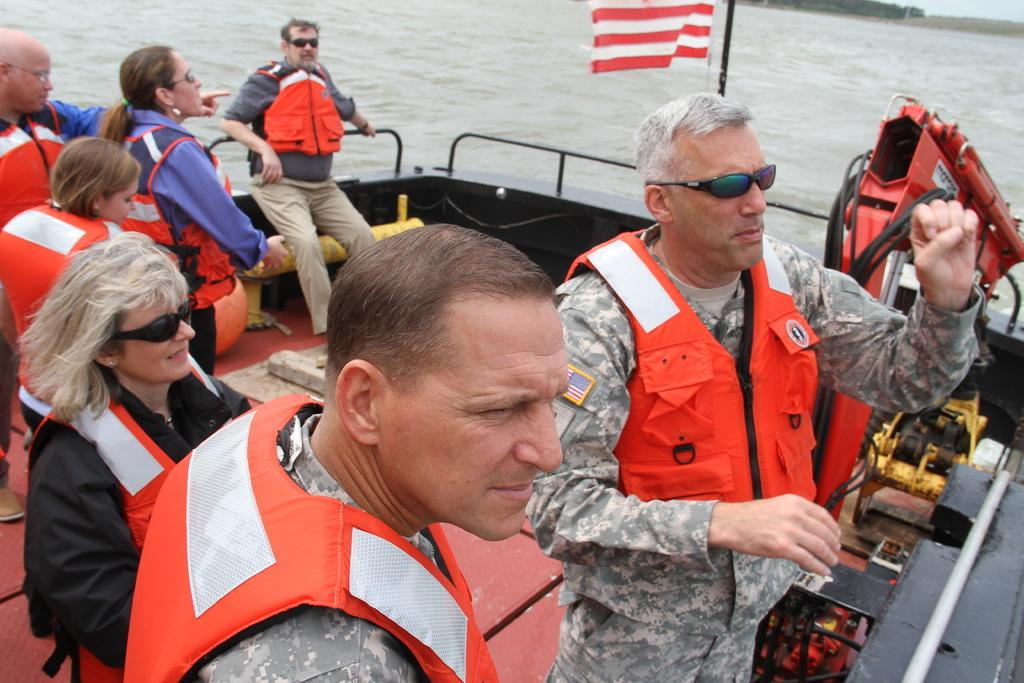How many people are in the image? There is a group of persons in the image. What are the persons doing in the image? The persons are standing in a boat. What are the persons wearing in the image? The persons are wearing safety jackets. What is the setting of the image? There is water visible in the image, and there are trees present. How many nails can be seen in the image? There are no nails visible in the image. What type of frogs are present in the image? There are no frogs present in the image. 